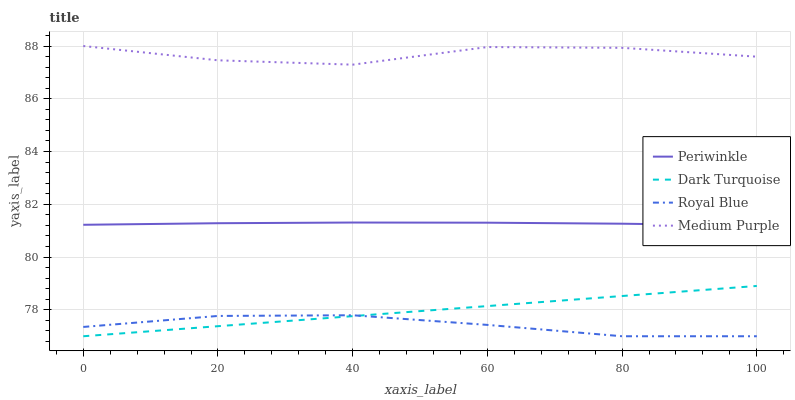Does Dark Turquoise have the minimum area under the curve?
Answer yes or no. No. Does Dark Turquoise have the maximum area under the curve?
Answer yes or no. No. Is Periwinkle the smoothest?
Answer yes or no. No. Is Periwinkle the roughest?
Answer yes or no. No. Does Periwinkle have the lowest value?
Answer yes or no. No. Does Dark Turquoise have the highest value?
Answer yes or no. No. Is Periwinkle less than Medium Purple?
Answer yes or no. Yes. Is Medium Purple greater than Periwinkle?
Answer yes or no. Yes. Does Periwinkle intersect Medium Purple?
Answer yes or no. No. 